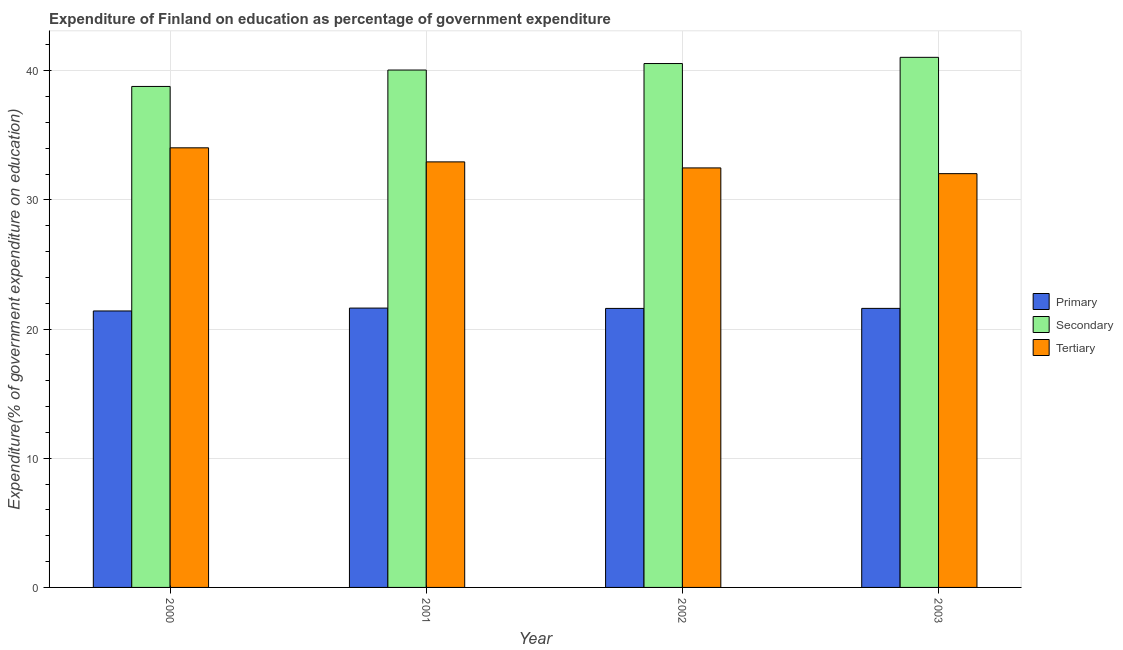How many different coloured bars are there?
Your answer should be compact. 3. How many groups of bars are there?
Keep it short and to the point. 4. How many bars are there on the 3rd tick from the right?
Provide a short and direct response. 3. What is the label of the 2nd group of bars from the left?
Provide a succinct answer. 2001. In how many cases, is the number of bars for a given year not equal to the number of legend labels?
Give a very brief answer. 0. What is the expenditure on secondary education in 2000?
Keep it short and to the point. 38.78. Across all years, what is the maximum expenditure on primary education?
Your response must be concise. 21.62. Across all years, what is the minimum expenditure on primary education?
Provide a short and direct response. 21.4. In which year was the expenditure on secondary education minimum?
Provide a short and direct response. 2000. What is the total expenditure on primary education in the graph?
Offer a terse response. 86.23. What is the difference between the expenditure on secondary education in 2001 and that in 2003?
Your answer should be very brief. -0.98. What is the difference between the expenditure on secondary education in 2000 and the expenditure on primary education in 2002?
Your answer should be compact. -1.77. What is the average expenditure on primary education per year?
Keep it short and to the point. 21.56. In the year 2000, what is the difference between the expenditure on tertiary education and expenditure on primary education?
Offer a very short reply. 0. What is the ratio of the expenditure on tertiary education in 2001 to that in 2003?
Your response must be concise. 1.03. Is the difference between the expenditure on primary education in 2002 and 2003 greater than the difference between the expenditure on tertiary education in 2002 and 2003?
Your response must be concise. No. What is the difference between the highest and the second highest expenditure on secondary education?
Make the answer very short. 0.48. What is the difference between the highest and the lowest expenditure on primary education?
Ensure brevity in your answer.  0.22. In how many years, is the expenditure on primary education greater than the average expenditure on primary education taken over all years?
Your answer should be compact. 3. What does the 2nd bar from the left in 2002 represents?
Give a very brief answer. Secondary. What does the 1st bar from the right in 2002 represents?
Keep it short and to the point. Tertiary. Is it the case that in every year, the sum of the expenditure on primary education and expenditure on secondary education is greater than the expenditure on tertiary education?
Your answer should be very brief. Yes. What is the difference between two consecutive major ticks on the Y-axis?
Keep it short and to the point. 10. Where does the legend appear in the graph?
Provide a succinct answer. Center right. How many legend labels are there?
Provide a succinct answer. 3. How are the legend labels stacked?
Keep it short and to the point. Vertical. What is the title of the graph?
Your response must be concise. Expenditure of Finland on education as percentage of government expenditure. Does "Fuel" appear as one of the legend labels in the graph?
Provide a short and direct response. No. What is the label or title of the X-axis?
Your answer should be very brief. Year. What is the label or title of the Y-axis?
Provide a succinct answer. Expenditure(% of government expenditure on education). What is the Expenditure(% of government expenditure on education) in Primary in 2000?
Provide a short and direct response. 21.4. What is the Expenditure(% of government expenditure on education) in Secondary in 2000?
Provide a short and direct response. 38.78. What is the Expenditure(% of government expenditure on education) in Tertiary in 2000?
Keep it short and to the point. 34.03. What is the Expenditure(% of government expenditure on education) of Primary in 2001?
Offer a very short reply. 21.62. What is the Expenditure(% of government expenditure on education) of Secondary in 2001?
Offer a very short reply. 40.05. What is the Expenditure(% of government expenditure on education) in Tertiary in 2001?
Ensure brevity in your answer.  32.94. What is the Expenditure(% of government expenditure on education) in Primary in 2002?
Your response must be concise. 21.6. What is the Expenditure(% of government expenditure on education) of Secondary in 2002?
Offer a terse response. 40.55. What is the Expenditure(% of government expenditure on education) in Tertiary in 2002?
Give a very brief answer. 32.47. What is the Expenditure(% of government expenditure on education) in Primary in 2003?
Make the answer very short. 21.6. What is the Expenditure(% of government expenditure on education) of Secondary in 2003?
Ensure brevity in your answer.  41.04. What is the Expenditure(% of government expenditure on education) of Tertiary in 2003?
Offer a very short reply. 32.03. Across all years, what is the maximum Expenditure(% of government expenditure on education) of Primary?
Your answer should be compact. 21.62. Across all years, what is the maximum Expenditure(% of government expenditure on education) of Secondary?
Your answer should be compact. 41.04. Across all years, what is the maximum Expenditure(% of government expenditure on education) in Tertiary?
Ensure brevity in your answer.  34.03. Across all years, what is the minimum Expenditure(% of government expenditure on education) of Primary?
Provide a succinct answer. 21.4. Across all years, what is the minimum Expenditure(% of government expenditure on education) in Secondary?
Your answer should be very brief. 38.78. Across all years, what is the minimum Expenditure(% of government expenditure on education) in Tertiary?
Offer a very short reply. 32.03. What is the total Expenditure(% of government expenditure on education) of Primary in the graph?
Your answer should be compact. 86.23. What is the total Expenditure(% of government expenditure on education) in Secondary in the graph?
Your answer should be very brief. 160.42. What is the total Expenditure(% of government expenditure on education) in Tertiary in the graph?
Your answer should be compact. 131.48. What is the difference between the Expenditure(% of government expenditure on education) of Primary in 2000 and that in 2001?
Offer a very short reply. -0.22. What is the difference between the Expenditure(% of government expenditure on education) in Secondary in 2000 and that in 2001?
Your answer should be compact. -1.27. What is the difference between the Expenditure(% of government expenditure on education) in Tertiary in 2000 and that in 2001?
Ensure brevity in your answer.  1.09. What is the difference between the Expenditure(% of government expenditure on education) of Primary in 2000 and that in 2002?
Offer a terse response. -0.2. What is the difference between the Expenditure(% of government expenditure on education) in Secondary in 2000 and that in 2002?
Keep it short and to the point. -1.77. What is the difference between the Expenditure(% of government expenditure on education) in Tertiary in 2000 and that in 2002?
Provide a short and direct response. 1.56. What is the difference between the Expenditure(% of government expenditure on education) in Primary in 2000 and that in 2003?
Your response must be concise. -0.2. What is the difference between the Expenditure(% of government expenditure on education) in Secondary in 2000 and that in 2003?
Make the answer very short. -2.25. What is the difference between the Expenditure(% of government expenditure on education) of Tertiary in 2000 and that in 2003?
Give a very brief answer. 2. What is the difference between the Expenditure(% of government expenditure on education) of Primary in 2001 and that in 2002?
Offer a very short reply. 0.03. What is the difference between the Expenditure(% of government expenditure on education) in Secondary in 2001 and that in 2002?
Your answer should be very brief. -0.5. What is the difference between the Expenditure(% of government expenditure on education) of Tertiary in 2001 and that in 2002?
Offer a terse response. 0.47. What is the difference between the Expenditure(% of government expenditure on education) of Primary in 2001 and that in 2003?
Your answer should be very brief. 0.02. What is the difference between the Expenditure(% of government expenditure on education) in Secondary in 2001 and that in 2003?
Keep it short and to the point. -0.98. What is the difference between the Expenditure(% of government expenditure on education) in Tertiary in 2001 and that in 2003?
Your answer should be compact. 0.91. What is the difference between the Expenditure(% of government expenditure on education) in Primary in 2002 and that in 2003?
Make the answer very short. -0. What is the difference between the Expenditure(% of government expenditure on education) in Secondary in 2002 and that in 2003?
Your response must be concise. -0.48. What is the difference between the Expenditure(% of government expenditure on education) in Tertiary in 2002 and that in 2003?
Offer a very short reply. 0.44. What is the difference between the Expenditure(% of government expenditure on education) of Primary in 2000 and the Expenditure(% of government expenditure on education) of Secondary in 2001?
Provide a succinct answer. -18.65. What is the difference between the Expenditure(% of government expenditure on education) in Primary in 2000 and the Expenditure(% of government expenditure on education) in Tertiary in 2001?
Your response must be concise. -11.54. What is the difference between the Expenditure(% of government expenditure on education) of Secondary in 2000 and the Expenditure(% of government expenditure on education) of Tertiary in 2001?
Give a very brief answer. 5.84. What is the difference between the Expenditure(% of government expenditure on education) in Primary in 2000 and the Expenditure(% of government expenditure on education) in Secondary in 2002?
Offer a terse response. -19.15. What is the difference between the Expenditure(% of government expenditure on education) of Primary in 2000 and the Expenditure(% of government expenditure on education) of Tertiary in 2002?
Offer a terse response. -11.07. What is the difference between the Expenditure(% of government expenditure on education) of Secondary in 2000 and the Expenditure(% of government expenditure on education) of Tertiary in 2002?
Your answer should be compact. 6.31. What is the difference between the Expenditure(% of government expenditure on education) of Primary in 2000 and the Expenditure(% of government expenditure on education) of Secondary in 2003?
Your response must be concise. -19.63. What is the difference between the Expenditure(% of government expenditure on education) in Primary in 2000 and the Expenditure(% of government expenditure on education) in Tertiary in 2003?
Make the answer very short. -10.63. What is the difference between the Expenditure(% of government expenditure on education) in Secondary in 2000 and the Expenditure(% of government expenditure on education) in Tertiary in 2003?
Make the answer very short. 6.75. What is the difference between the Expenditure(% of government expenditure on education) of Primary in 2001 and the Expenditure(% of government expenditure on education) of Secondary in 2002?
Make the answer very short. -18.93. What is the difference between the Expenditure(% of government expenditure on education) in Primary in 2001 and the Expenditure(% of government expenditure on education) in Tertiary in 2002?
Your answer should be compact. -10.85. What is the difference between the Expenditure(% of government expenditure on education) of Secondary in 2001 and the Expenditure(% of government expenditure on education) of Tertiary in 2002?
Make the answer very short. 7.58. What is the difference between the Expenditure(% of government expenditure on education) in Primary in 2001 and the Expenditure(% of government expenditure on education) in Secondary in 2003?
Provide a short and direct response. -19.41. What is the difference between the Expenditure(% of government expenditure on education) in Primary in 2001 and the Expenditure(% of government expenditure on education) in Tertiary in 2003?
Your answer should be compact. -10.41. What is the difference between the Expenditure(% of government expenditure on education) in Secondary in 2001 and the Expenditure(% of government expenditure on education) in Tertiary in 2003?
Provide a short and direct response. 8.02. What is the difference between the Expenditure(% of government expenditure on education) in Primary in 2002 and the Expenditure(% of government expenditure on education) in Secondary in 2003?
Offer a very short reply. -19.44. What is the difference between the Expenditure(% of government expenditure on education) in Primary in 2002 and the Expenditure(% of government expenditure on education) in Tertiary in 2003?
Keep it short and to the point. -10.43. What is the difference between the Expenditure(% of government expenditure on education) of Secondary in 2002 and the Expenditure(% of government expenditure on education) of Tertiary in 2003?
Make the answer very short. 8.52. What is the average Expenditure(% of government expenditure on education) in Primary per year?
Your answer should be very brief. 21.56. What is the average Expenditure(% of government expenditure on education) of Secondary per year?
Provide a short and direct response. 40.11. What is the average Expenditure(% of government expenditure on education) of Tertiary per year?
Give a very brief answer. 32.87. In the year 2000, what is the difference between the Expenditure(% of government expenditure on education) of Primary and Expenditure(% of government expenditure on education) of Secondary?
Offer a terse response. -17.38. In the year 2000, what is the difference between the Expenditure(% of government expenditure on education) of Primary and Expenditure(% of government expenditure on education) of Tertiary?
Keep it short and to the point. -12.63. In the year 2000, what is the difference between the Expenditure(% of government expenditure on education) of Secondary and Expenditure(% of government expenditure on education) of Tertiary?
Give a very brief answer. 4.75. In the year 2001, what is the difference between the Expenditure(% of government expenditure on education) in Primary and Expenditure(% of government expenditure on education) in Secondary?
Provide a succinct answer. -18.43. In the year 2001, what is the difference between the Expenditure(% of government expenditure on education) of Primary and Expenditure(% of government expenditure on education) of Tertiary?
Give a very brief answer. -11.32. In the year 2001, what is the difference between the Expenditure(% of government expenditure on education) of Secondary and Expenditure(% of government expenditure on education) of Tertiary?
Keep it short and to the point. 7.11. In the year 2002, what is the difference between the Expenditure(% of government expenditure on education) in Primary and Expenditure(% of government expenditure on education) in Secondary?
Your response must be concise. -18.96. In the year 2002, what is the difference between the Expenditure(% of government expenditure on education) of Primary and Expenditure(% of government expenditure on education) of Tertiary?
Your answer should be very brief. -10.88. In the year 2002, what is the difference between the Expenditure(% of government expenditure on education) in Secondary and Expenditure(% of government expenditure on education) in Tertiary?
Your answer should be very brief. 8.08. In the year 2003, what is the difference between the Expenditure(% of government expenditure on education) in Primary and Expenditure(% of government expenditure on education) in Secondary?
Ensure brevity in your answer.  -19.43. In the year 2003, what is the difference between the Expenditure(% of government expenditure on education) of Primary and Expenditure(% of government expenditure on education) of Tertiary?
Your answer should be very brief. -10.43. In the year 2003, what is the difference between the Expenditure(% of government expenditure on education) of Secondary and Expenditure(% of government expenditure on education) of Tertiary?
Provide a succinct answer. 9. What is the ratio of the Expenditure(% of government expenditure on education) of Secondary in 2000 to that in 2001?
Make the answer very short. 0.97. What is the ratio of the Expenditure(% of government expenditure on education) of Tertiary in 2000 to that in 2001?
Ensure brevity in your answer.  1.03. What is the ratio of the Expenditure(% of government expenditure on education) of Primary in 2000 to that in 2002?
Keep it short and to the point. 0.99. What is the ratio of the Expenditure(% of government expenditure on education) in Secondary in 2000 to that in 2002?
Ensure brevity in your answer.  0.96. What is the ratio of the Expenditure(% of government expenditure on education) of Tertiary in 2000 to that in 2002?
Provide a succinct answer. 1.05. What is the ratio of the Expenditure(% of government expenditure on education) of Primary in 2000 to that in 2003?
Give a very brief answer. 0.99. What is the ratio of the Expenditure(% of government expenditure on education) in Secondary in 2000 to that in 2003?
Keep it short and to the point. 0.95. What is the ratio of the Expenditure(% of government expenditure on education) in Tertiary in 2000 to that in 2003?
Offer a terse response. 1.06. What is the ratio of the Expenditure(% of government expenditure on education) of Primary in 2001 to that in 2002?
Make the answer very short. 1. What is the ratio of the Expenditure(% of government expenditure on education) in Secondary in 2001 to that in 2002?
Your response must be concise. 0.99. What is the ratio of the Expenditure(% of government expenditure on education) in Tertiary in 2001 to that in 2002?
Provide a short and direct response. 1.01. What is the ratio of the Expenditure(% of government expenditure on education) in Primary in 2001 to that in 2003?
Provide a succinct answer. 1. What is the ratio of the Expenditure(% of government expenditure on education) of Secondary in 2001 to that in 2003?
Offer a very short reply. 0.98. What is the ratio of the Expenditure(% of government expenditure on education) in Tertiary in 2001 to that in 2003?
Offer a very short reply. 1.03. What is the ratio of the Expenditure(% of government expenditure on education) of Primary in 2002 to that in 2003?
Make the answer very short. 1. What is the ratio of the Expenditure(% of government expenditure on education) in Secondary in 2002 to that in 2003?
Make the answer very short. 0.99. What is the ratio of the Expenditure(% of government expenditure on education) of Tertiary in 2002 to that in 2003?
Give a very brief answer. 1.01. What is the difference between the highest and the second highest Expenditure(% of government expenditure on education) in Primary?
Provide a succinct answer. 0.02. What is the difference between the highest and the second highest Expenditure(% of government expenditure on education) in Secondary?
Provide a short and direct response. 0.48. What is the difference between the highest and the second highest Expenditure(% of government expenditure on education) in Tertiary?
Provide a succinct answer. 1.09. What is the difference between the highest and the lowest Expenditure(% of government expenditure on education) in Primary?
Your answer should be very brief. 0.22. What is the difference between the highest and the lowest Expenditure(% of government expenditure on education) of Secondary?
Provide a short and direct response. 2.25. What is the difference between the highest and the lowest Expenditure(% of government expenditure on education) in Tertiary?
Offer a terse response. 2. 